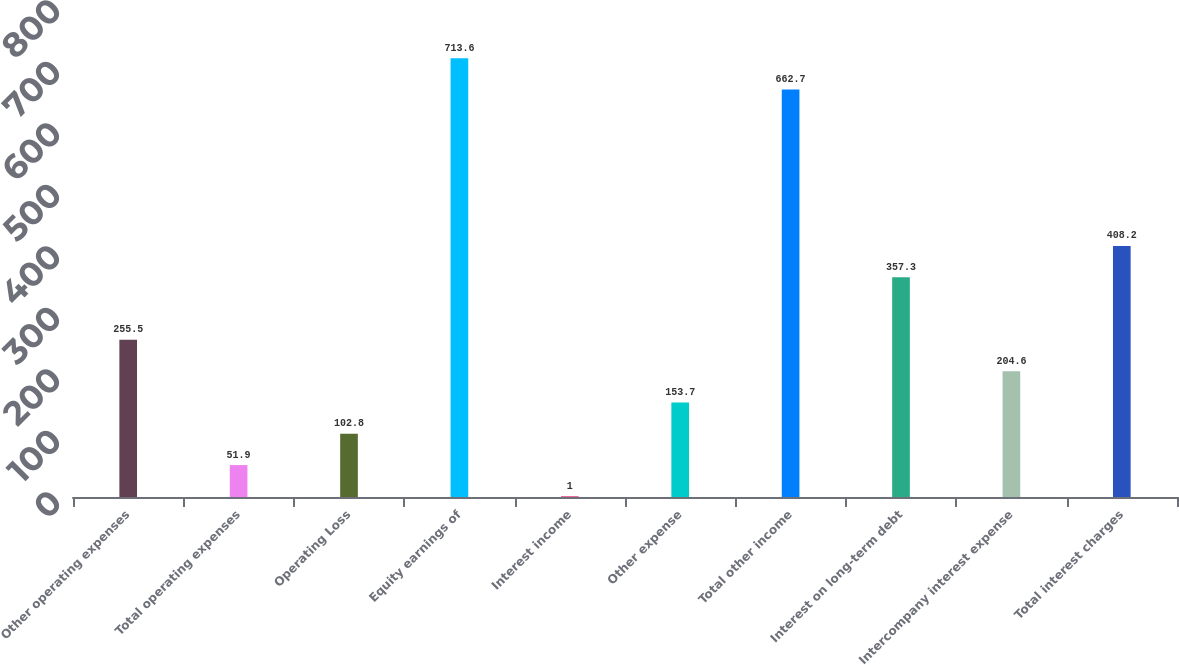<chart> <loc_0><loc_0><loc_500><loc_500><bar_chart><fcel>Other operating expenses<fcel>Total operating expenses<fcel>Operating Loss<fcel>Equity earnings of<fcel>Interest income<fcel>Other expense<fcel>Total other income<fcel>Interest on long-term debt<fcel>Intercompany interest expense<fcel>Total interest charges<nl><fcel>255.5<fcel>51.9<fcel>102.8<fcel>713.6<fcel>1<fcel>153.7<fcel>662.7<fcel>357.3<fcel>204.6<fcel>408.2<nl></chart> 